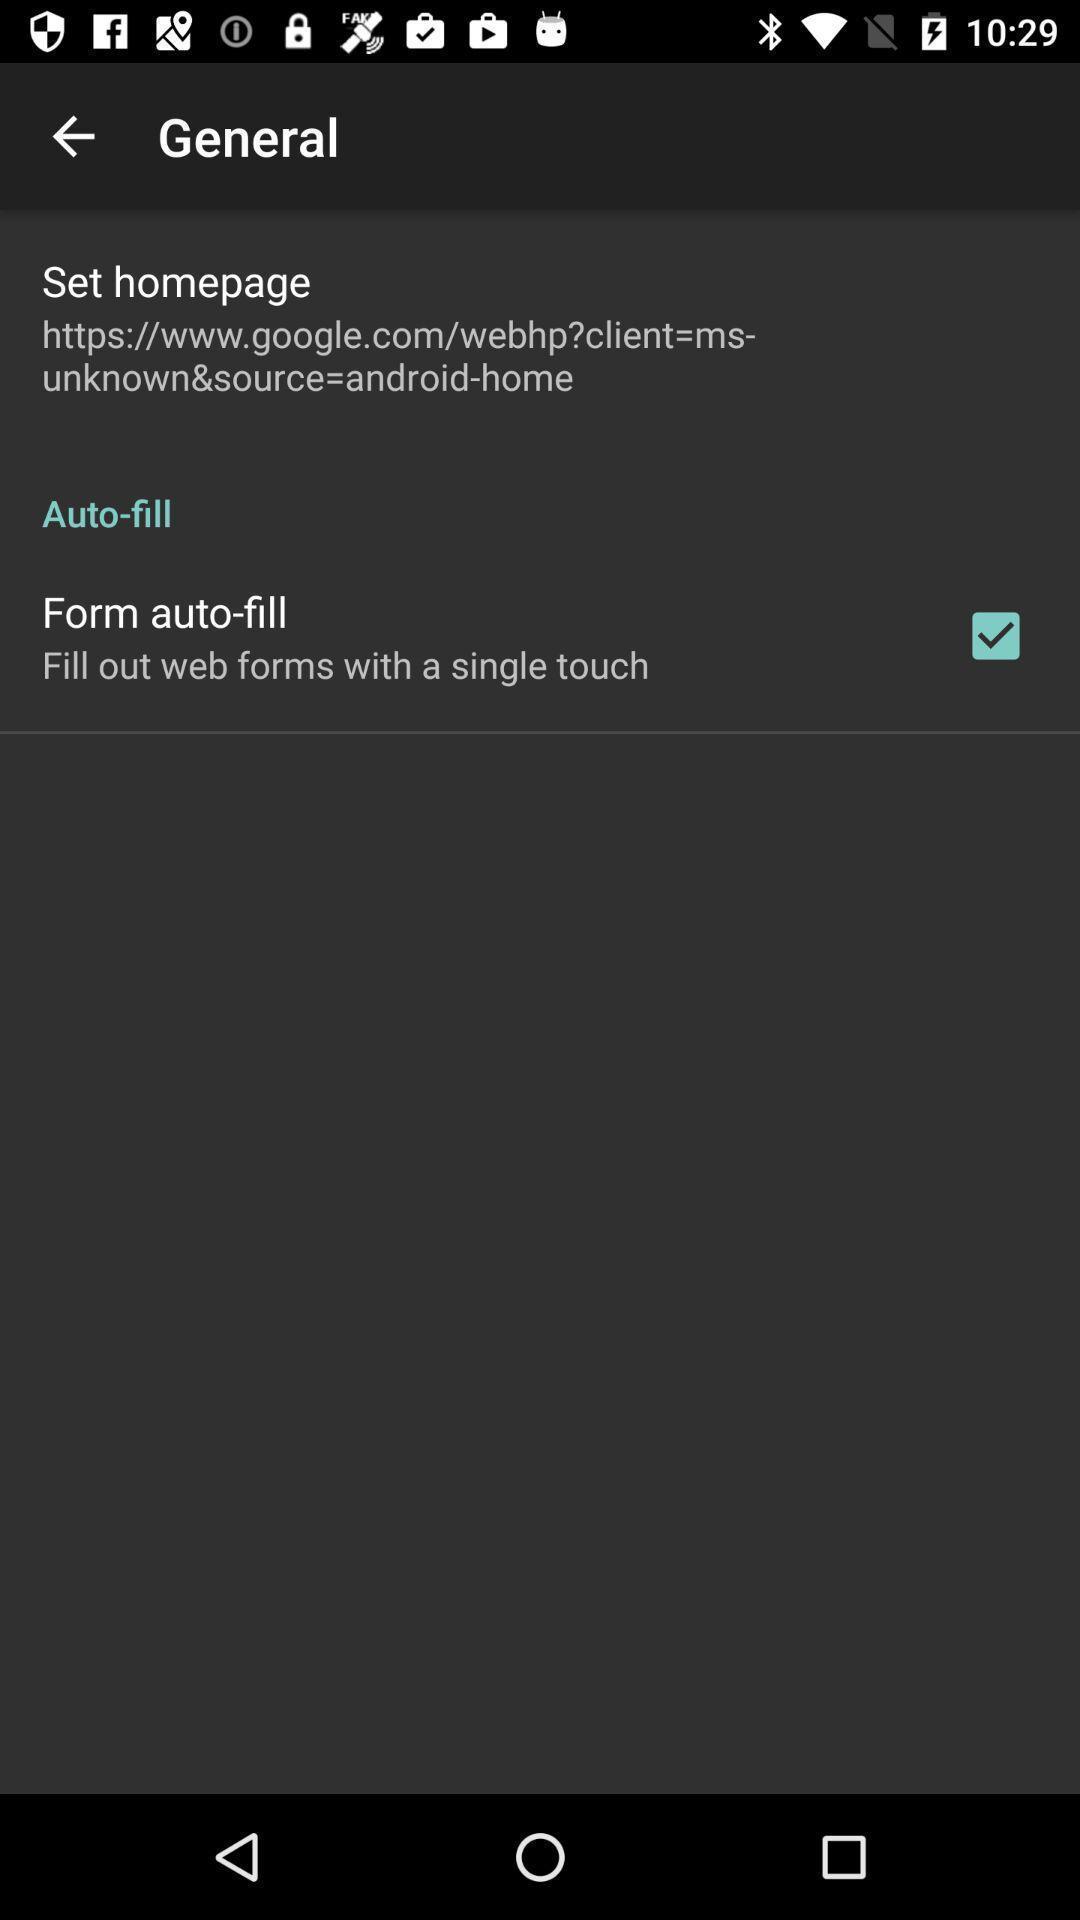Provide a textual representation of this image. Settings page. 